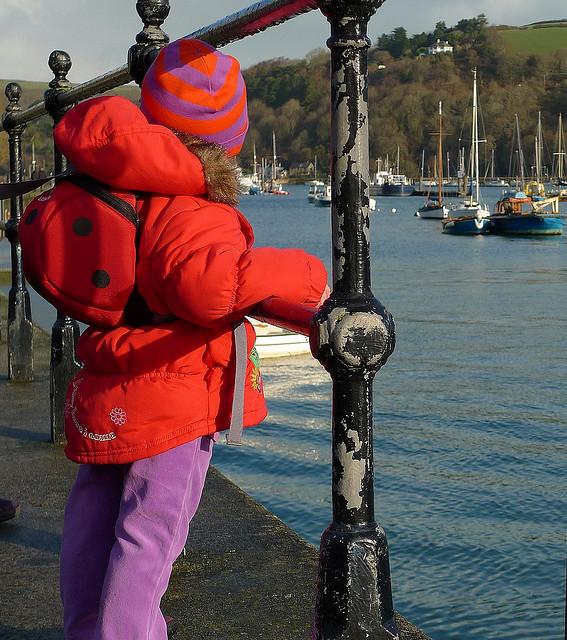What color is the child's coat?
Concise answer only. Red. What color are the child's pants?
Quick response, please. Purple. Is the child trying to cross a street?
Short answer required. No. 